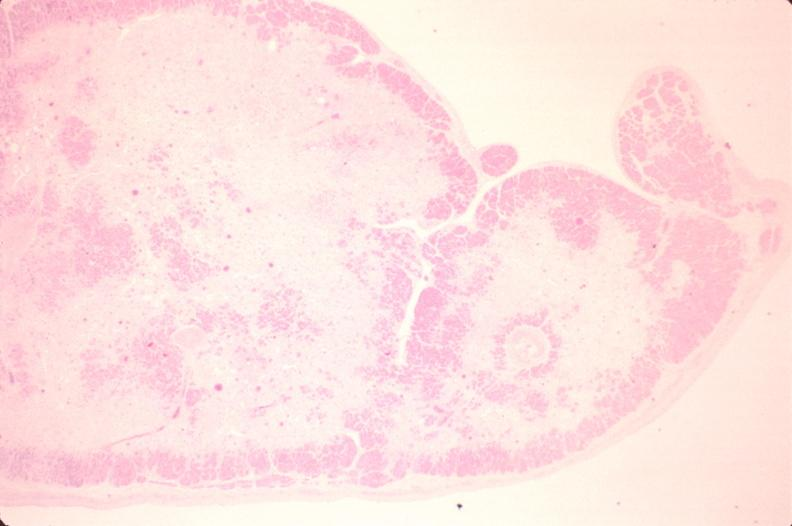where is this in?
Answer the question using a single word or phrase. In heart 